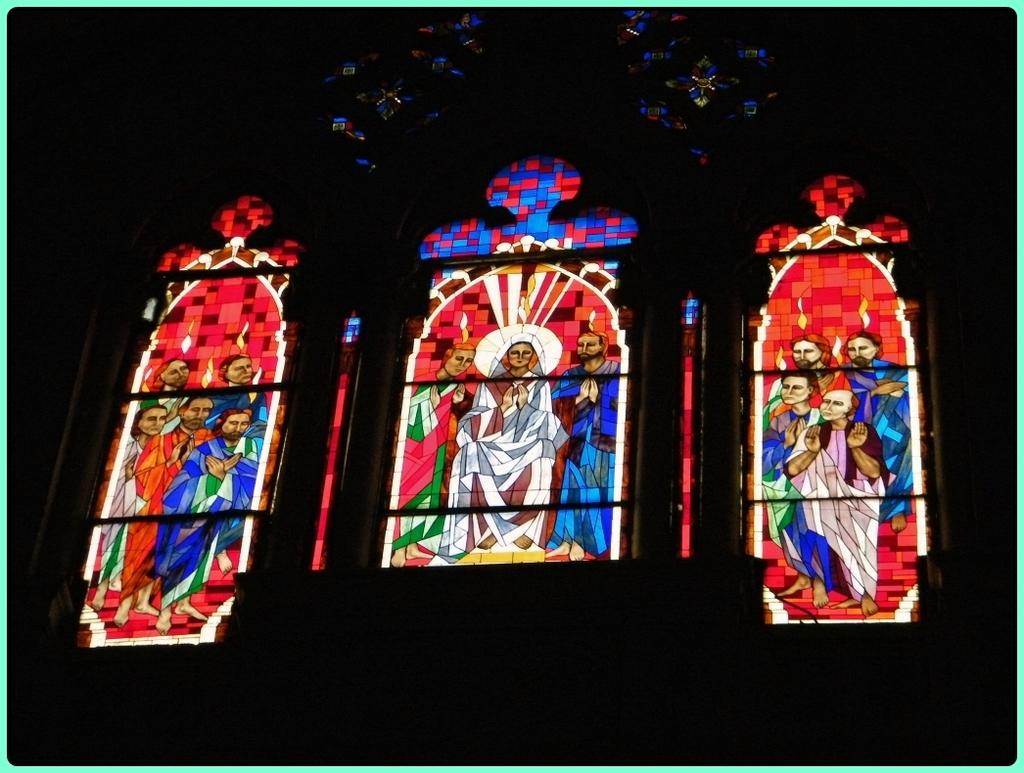What can be seen on the windows in the image? The windows have art displayed on them. Can you describe the art displayed on the windows? Unfortunately, the facts provided do not give a detailed description of the art displayed on the windows. What type of spot can be seen on the windows in the image? There is no mention of a spot on the windows in the image. What harbor can be seen in the image? There is no harbor present in the image. 